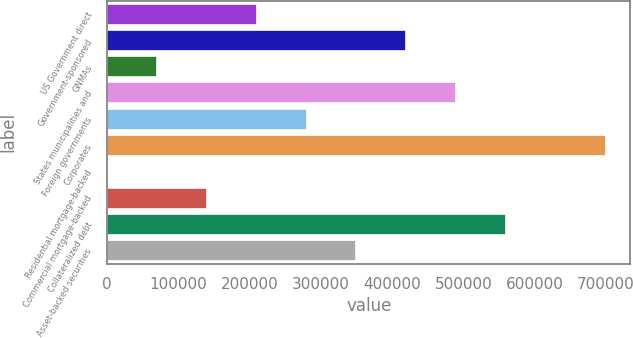Convert chart to OTSL. <chart><loc_0><loc_0><loc_500><loc_500><bar_chart><fcel>US Government direct<fcel>Government-sponsored<fcel>GNMAs<fcel>States municipalities and<fcel>Foreign governments<fcel>Corporates<fcel>Residential mortgage-backed<fcel>Commercial mortgage-backed<fcel>Collateralized debt<fcel>Asset-backed securities<nl><fcel>209782<fcel>419563<fcel>69928.8<fcel>489490<fcel>279709<fcel>699270<fcel>2.02<fcel>139856<fcel>559416<fcel>349636<nl></chart> 